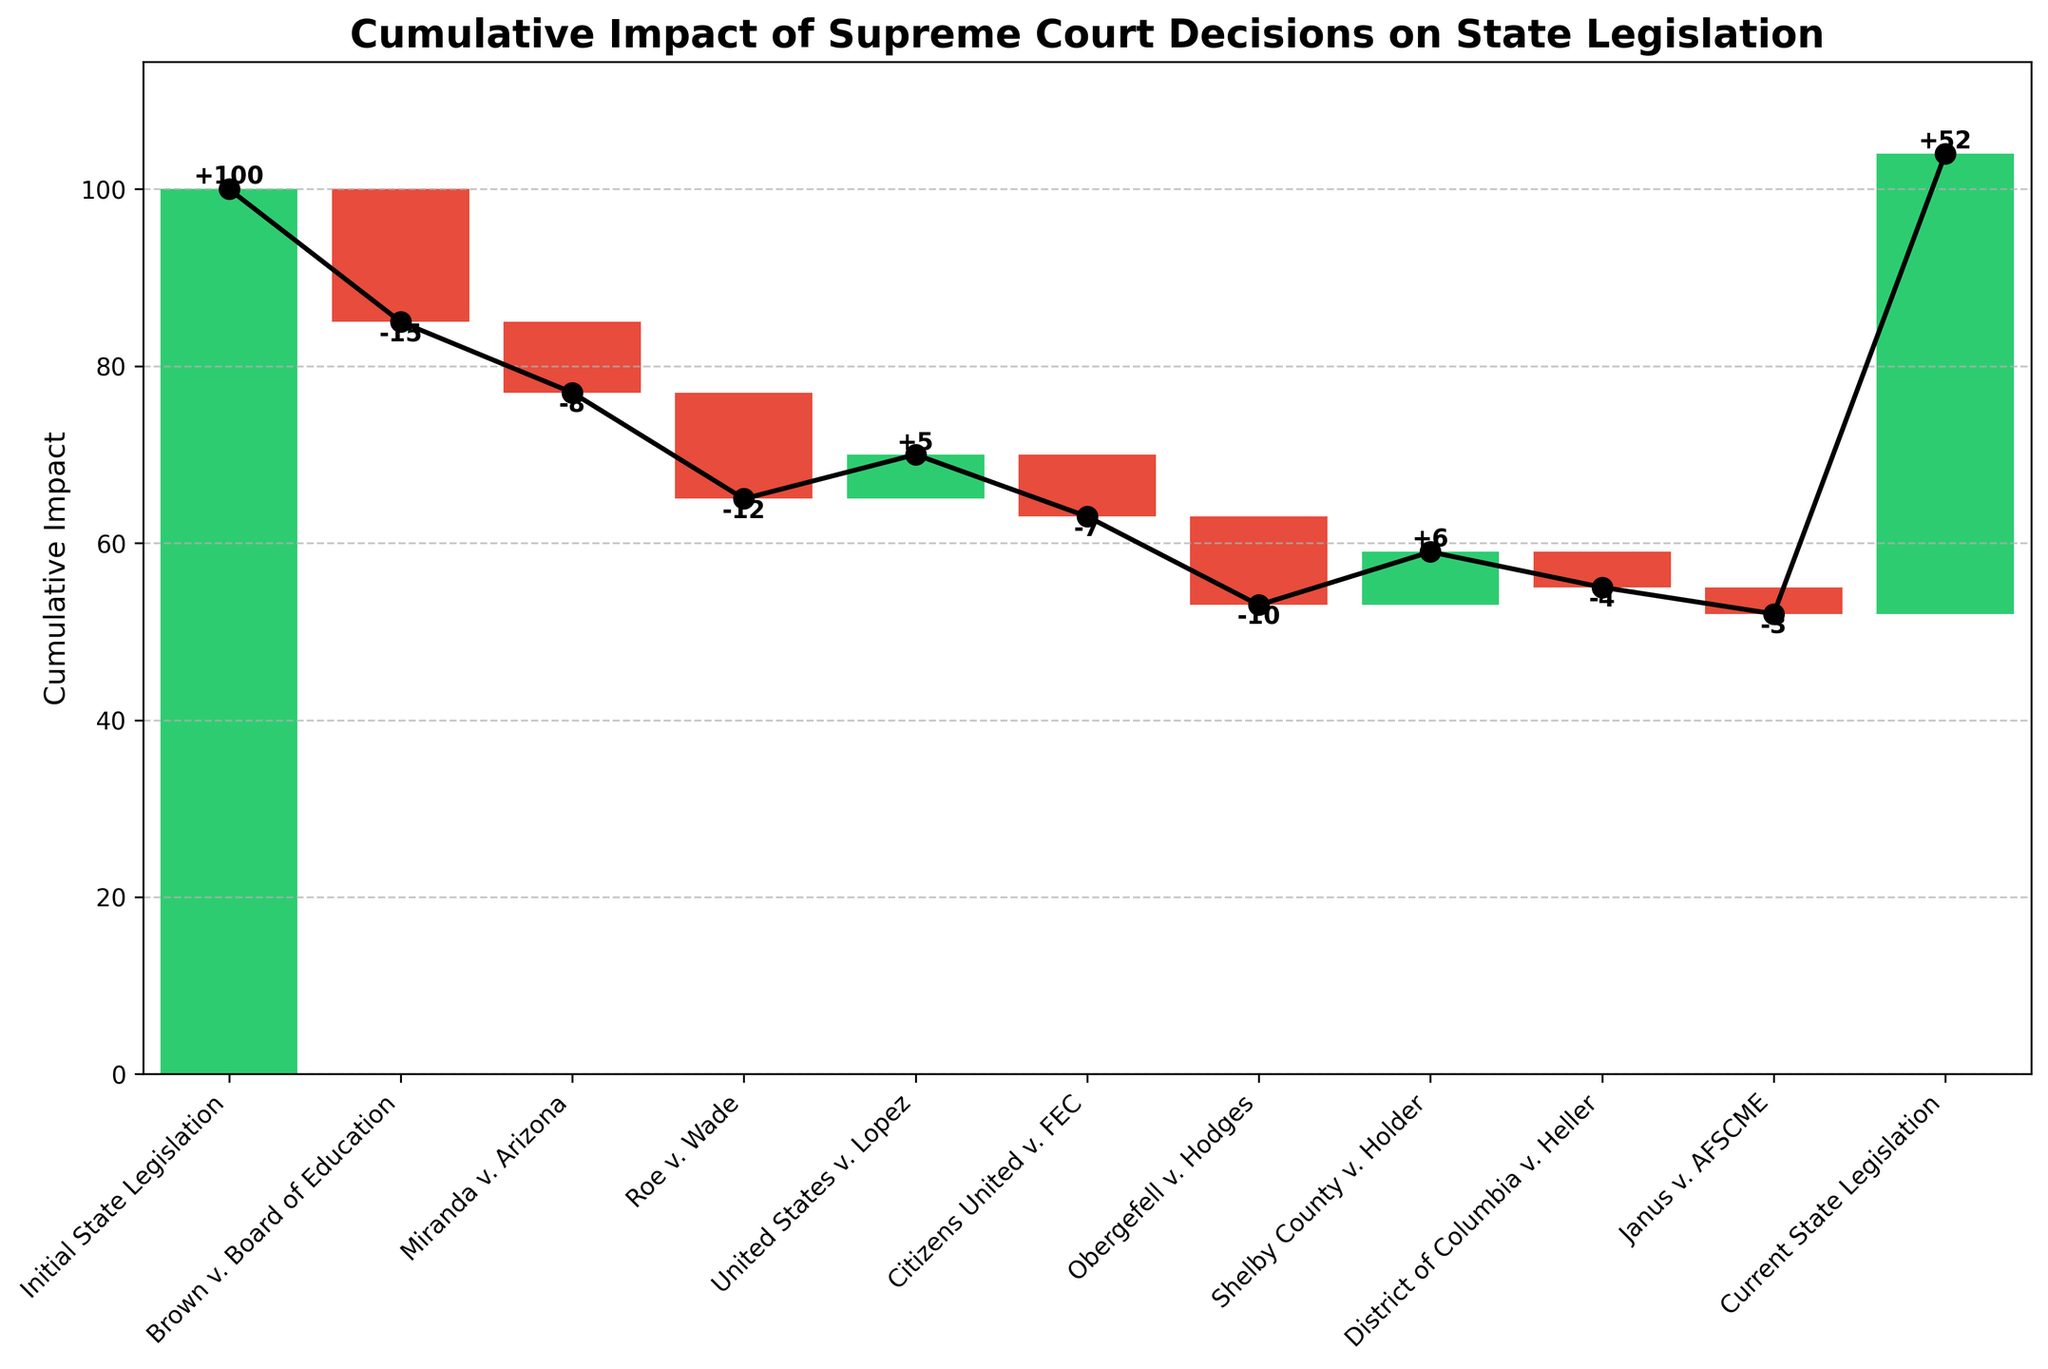What is the initial value for state legislation? The initial value is usually the starting point or the first data point in a waterfall chart, which represents the baseline before any impacts are added or subtracted. The chart shows that the initial state legislation value is 100.
Answer: 100 Which Supreme Court decision had the largest negative impact on state legislation? To find the largest negative impact, look for the bar with the most substantial drop below the baseline. In the chart, 'Roe v. Wade' results in a -12 impact, which is the largest negative value.
Answer: Roe v. Wade What is the cumulative impact after the Citizens United v. FEC decision? To find the cumulative impact after this decision, follow the cumulative line up to the point just before the next decision. 'Citizens United v. FEC' has a -7 impact. The total cumulative impact up to this point is 100 - 15 - 8 - 12 + 5 - 7 = 63.
Answer: 63 How much did the Shelby County v. Holder decision positively impact state legislation? Check the value associated with this decision and note the direction. Shelby County v. Holder had a positive impact of +6 on state legislation.
Answer: +6 What is the final cumulative impact on state legislation by the end of the chart? The final cumulative value can be seen at the end of the graph, which represents the 'Current State Legislation'. The cumulative value at this point is 52.
Answer: 52 How does the impact of District of Columbia v. Heller compare to Janus v. AFSCME? To compare these impacts, look at the values for both. 'District of Columbia v. Heller' has an impact of -4, whereas 'Janus v. AFSCME' has an impact of -3. 'District of Columbia v. Heller' has a slightly larger negative impact.
Answer: District of Columbia v. Heller has a larger negative impact What is the cumulative impact after the Roe v. Wade decision? Start with the initial value and add the impacts in sequence up to and including Roe v. Wade. This gives 100 - 15 - 8 - 12 = 65.
Answer: 65 Which Supreme Court decision had the smallest absolute impact on state legislation? Look for the smallest value in absolute terms among the impacts. The decision with the smallest absolute impact is 'Janus v. AFSCME' with a -3 impact.
Answer: Janus v. AFSCME What is the difference in cumulative impact between Brown v. Board of Education and Shelby County v. Holder? First, calculate the cumulative impact after each decision: 'Brown v. Board of Education' is 100 - 15 = 85; 'Shelby County v. Holder' is 100 - 15 - 8 - 12 + 5 - 7 - 10 + 6 = 49. The difference is 85 - 49 = 36.
Answer: 36 What is the title of the chart? The title of the chart is located at the top and states the overall topic of the visualization. In this case, it is 'Cumulative Impact of Supreme Court Decisions on State Legislation'.
Answer: Cumulative Impact of Supreme Court Decisions on State Legislation 